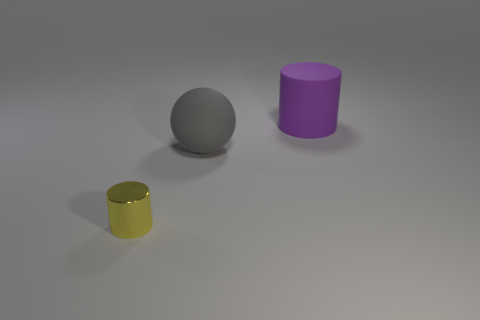Can you describe the lighting condition in the scene? The scene is lit with a soft, diffused overhead light that creates gentle shadows to the right of the objects, suggesting a single, soft light source from the upper left. This lighting provides a calm and clear visibility, highlighting the textures and colors of the objects effectively. 